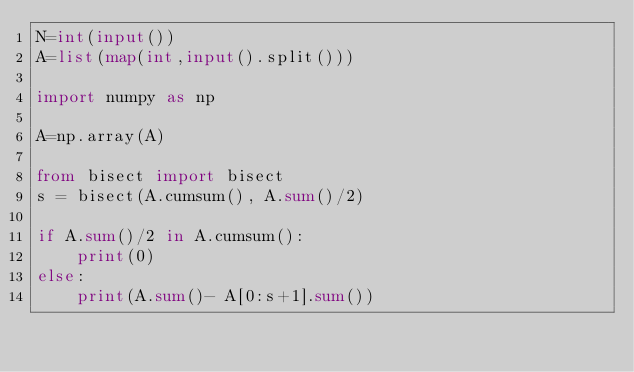Convert code to text. <code><loc_0><loc_0><loc_500><loc_500><_Python_>N=int(input())
A=list(map(int,input().split()))

import numpy as np

A=np.array(A)

from bisect import bisect
s = bisect(A.cumsum(), A.sum()/2)

if A.sum()/2 in A.cumsum():
    print(0)
else:
    print(A.sum()- A[0:s+1].sum())</code> 